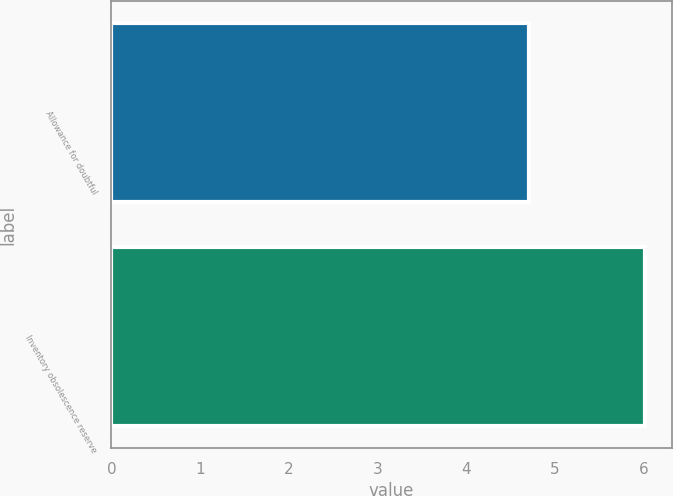Convert chart to OTSL. <chart><loc_0><loc_0><loc_500><loc_500><bar_chart><fcel>Allowance for doubtful<fcel>Inventory obsolescence reserve<nl><fcel>4.71<fcel>6.02<nl></chart> 